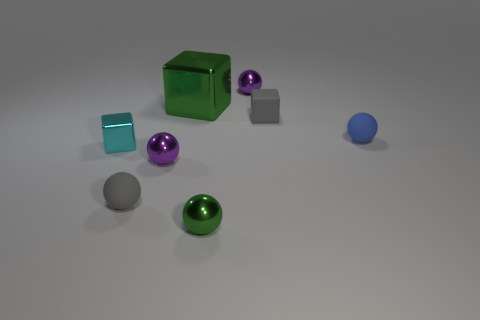Subtract 2 balls. How many balls are left? 3 Subtract all brown spheres. Subtract all cyan blocks. How many spheres are left? 5 Add 1 cyan matte objects. How many objects exist? 9 Subtract all balls. How many objects are left? 3 Subtract all small purple metal objects. Subtract all tiny cyan blocks. How many objects are left? 5 Add 4 rubber things. How many rubber things are left? 7 Add 3 big red metal objects. How many big red metal objects exist? 3 Subtract 0 blue cylinders. How many objects are left? 8 